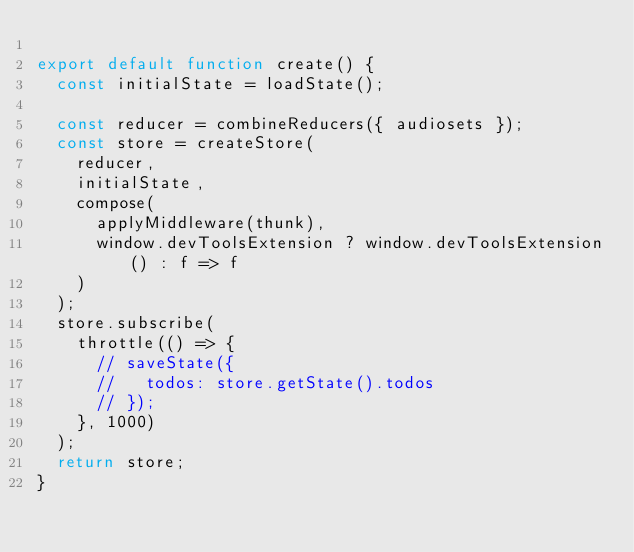Convert code to text. <code><loc_0><loc_0><loc_500><loc_500><_JavaScript_>
export default function create() {
  const initialState = loadState();

  const reducer = combineReducers({ audiosets });
  const store = createStore(
    reducer,
    initialState,
    compose(
      applyMiddleware(thunk),
      window.devToolsExtension ? window.devToolsExtension() : f => f
    )
  );
  store.subscribe(
    throttle(() => {
      // saveState({
      //   todos: store.getState().todos
      // });
    }, 1000)
  );
  return store;
}
</code> 